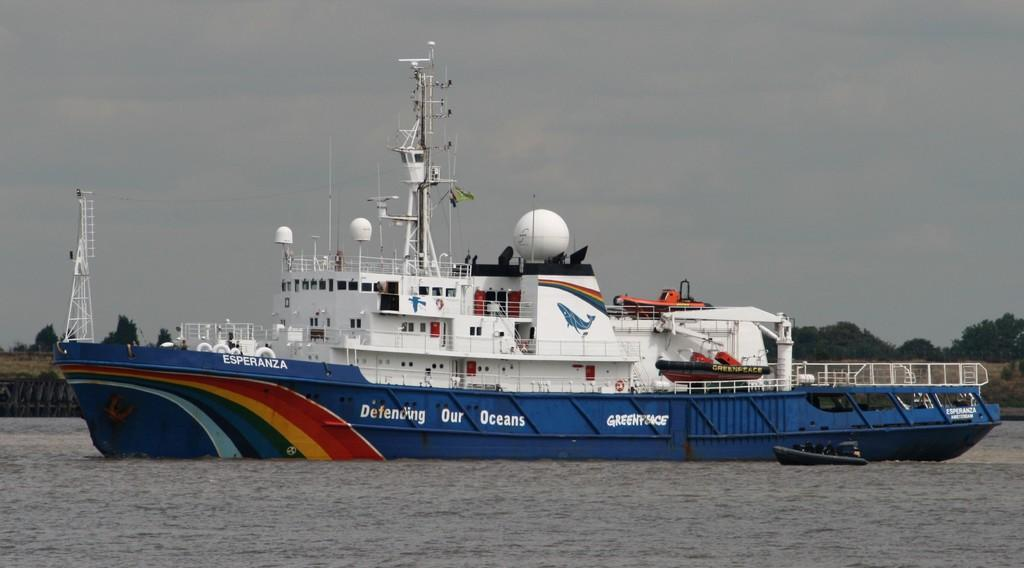Provide a one-sentence caption for the provided image. The blue ship Esperanza is defending our oceans. 